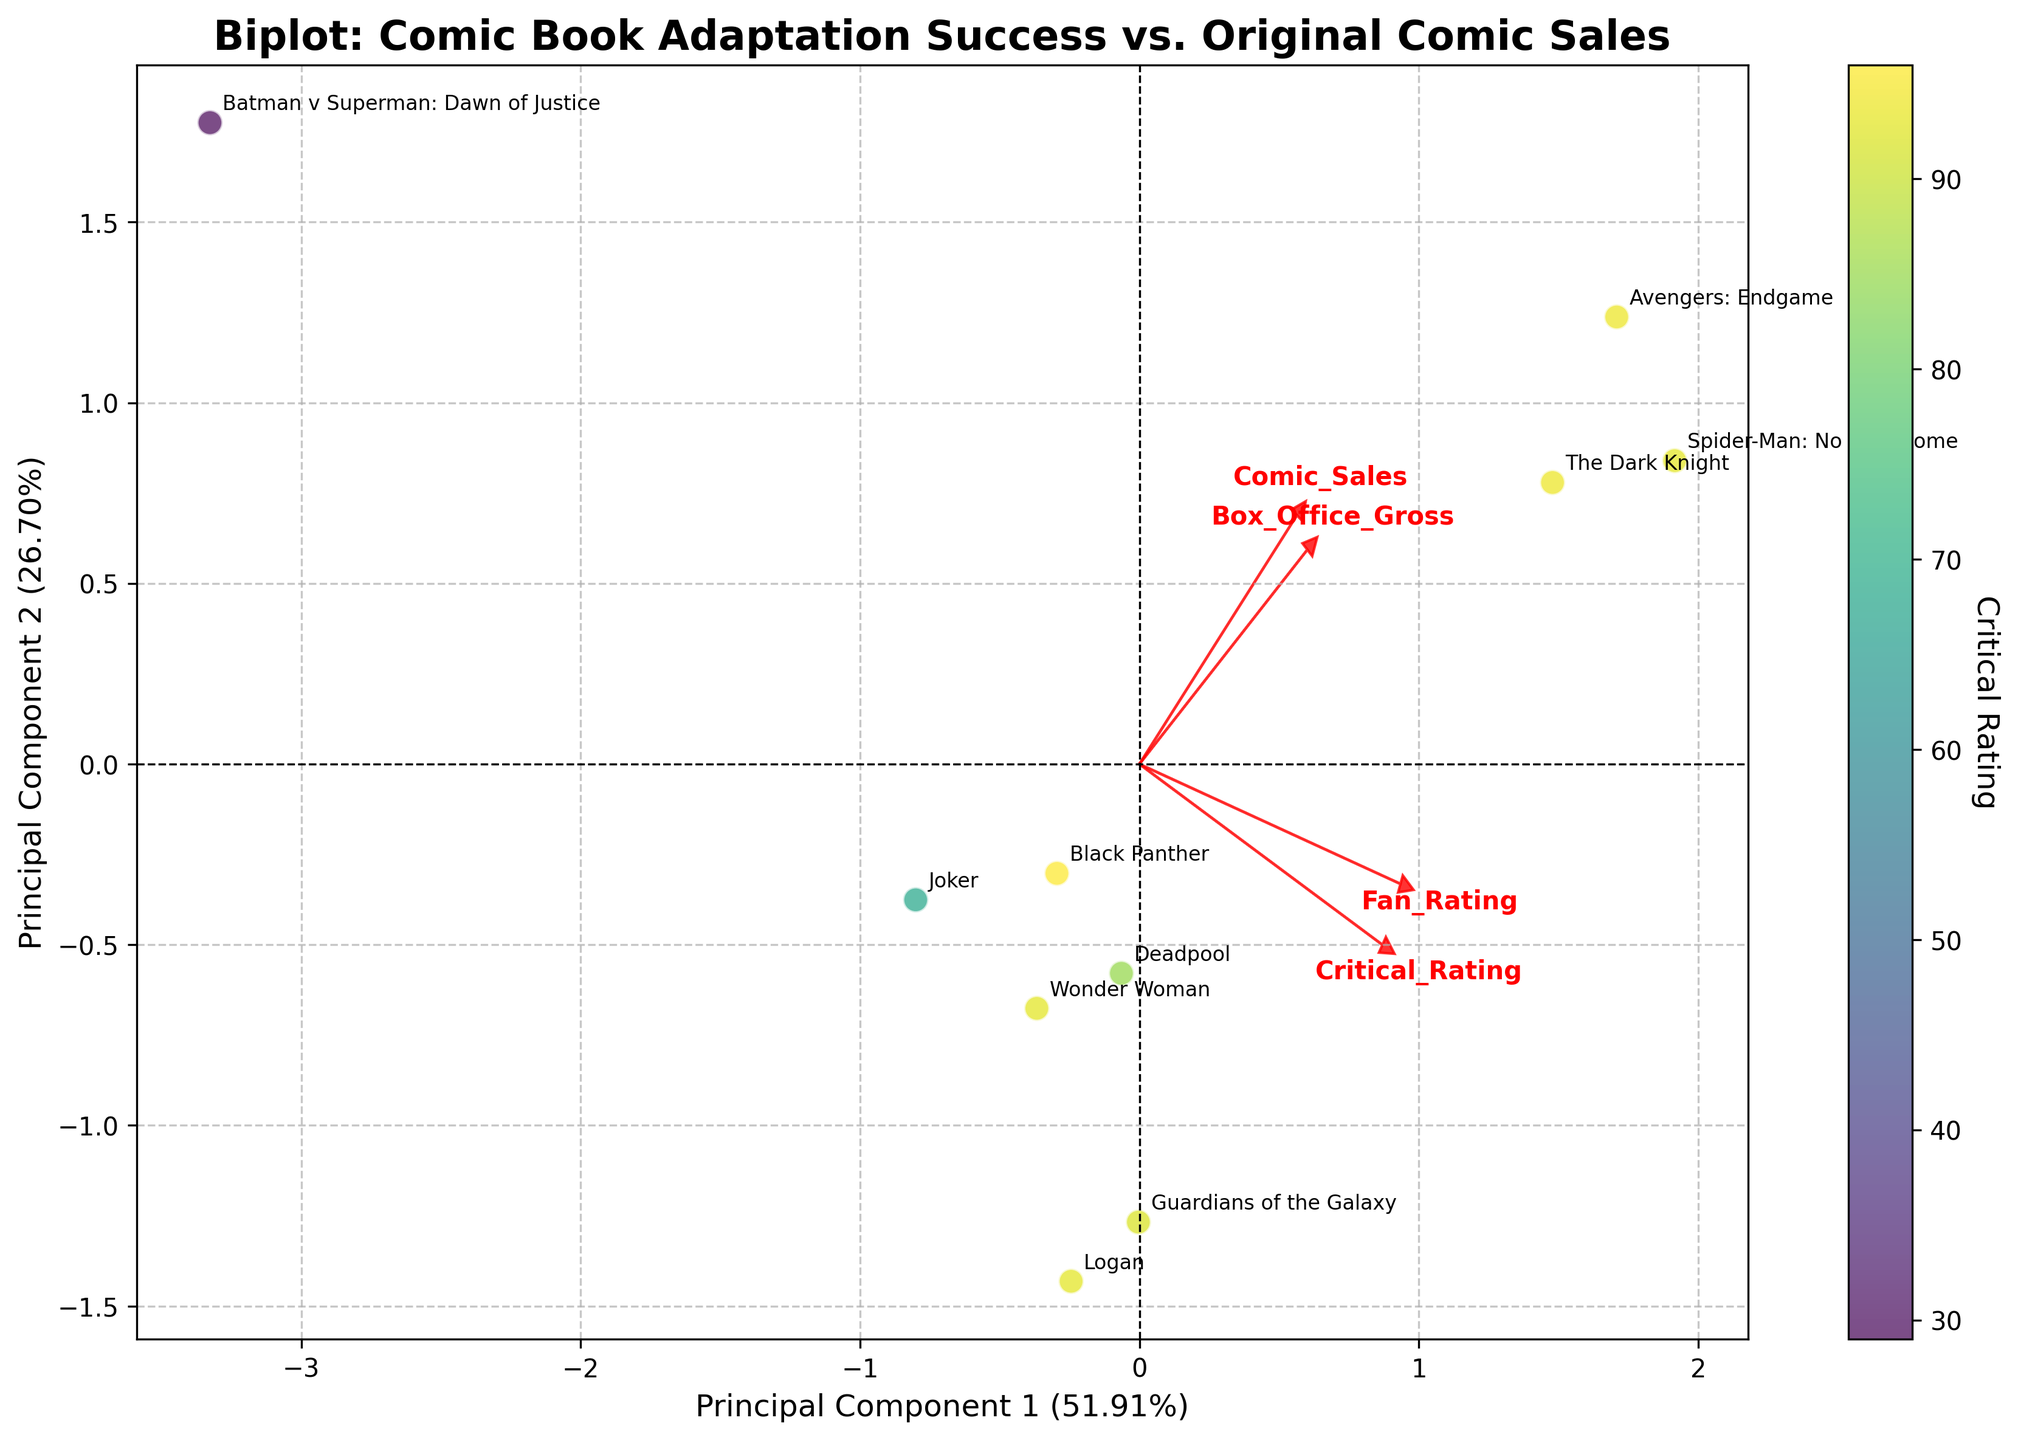How many comic book titles are represented on the plot? Count the number of unique comic book titles given in the annotations around the data points.
Answer: 10 What are the axes labeled on the plot? Look at the labels on the x-axis and y-axis of the plot.
Answer: Principal Component 1 and Principal Component 2 Which feature has the highest loading along Principal Component 1? Observe the red arrows representing the loadings. Check which arrow points farthest in the direction of Principal Component 1.
Answer: Comic_Sales Which comic book adaptation had the highest Critical Rating? Use the color of the scatter points to determine which has the highest Critical Rating. The colorbar indicates the gradient, with brighter colors representing higher ratings.
Answer: Black Panther How are Box_Office_Gross and Critical_Rating represented in the biplot? Look at the direction and length of the red arrows corresponding to these features.
Answer: As vectors (red arrows) with directions and lengths indicating influence Which two movies have the closest scatter points on the plot? Visually inspect the plot and find the two points that are nearest to each other.
Answer: Guardians of the Galaxy and Deadpool How are Fan_Rating and Comic_Sales correlated according to the plot? Look at the directions of the red arrows for Fan_Rating and Comic_Sales. If they point in similar directions, they are positively correlated; if opposite, negatively correlated; if perpendicular, uncorrelated.
Answer: They appear positively correlated What can be inferred if a point is far from the origin in this biplot? Points far from the origin indicate that the movie strongly exemplifies the characteristics corresponding to that direction in the feature space.
Answer: Strong characteristics Which movie had the highest Box_Office_Gross? Look at the annotations and find the point that corresponds to the highest value along the Box_Office_Gross loading arrow.
Answer: Avengers: Endgame How does Spider-Man: No Way Home compare to Batman v Superman: Dawn of Justice in terms of Critical Rating and Fan_Rating in the plot? Check the positions and the colors of the points corresponding to these movies. Spider-Man: No Way Home should have a brighter color and higher coordinates indicating better ratings.
Answer: Higher for both 